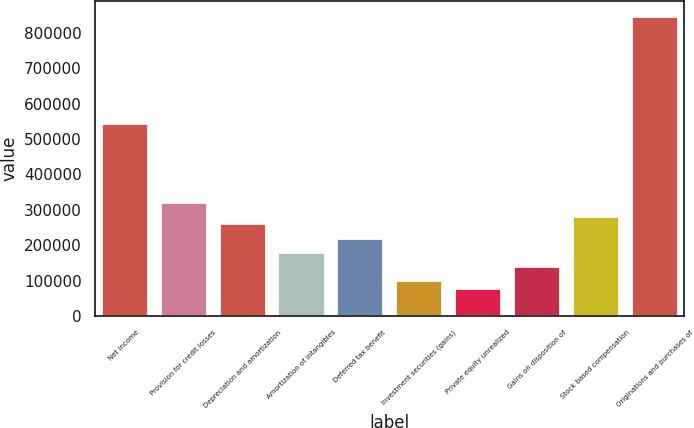Convert chart to OTSL. <chart><loc_0><loc_0><loc_500><loc_500><bar_chart><fcel>Net income<fcel>Provision for credit losses<fcel>Depreciation and amortization<fcel>Amortization of intangibles<fcel>Deferred tax benefit<fcel>Investment securities (gains)<fcel>Private equity unrealized<fcel>Gains on disposition of<fcel>Stock based compensation<fcel>Originations and purchases of<nl><fcel>544099<fcel>322437<fcel>261983<fcel>181379<fcel>221681<fcel>100774<fcel>80623.4<fcel>141077<fcel>282134<fcel>846365<nl></chart> 